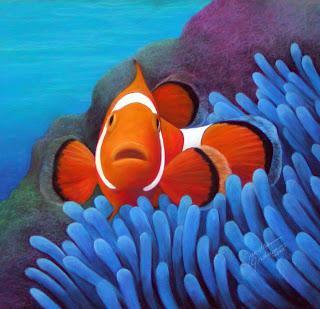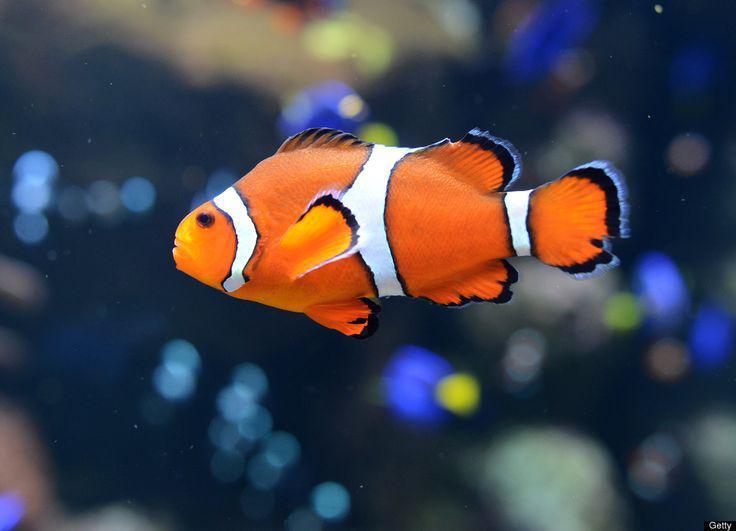The first image is the image on the left, the second image is the image on the right. Examine the images to the left and right. Is the description "there is one clownfish facing right on the right image" accurate? Answer yes or no. No. 